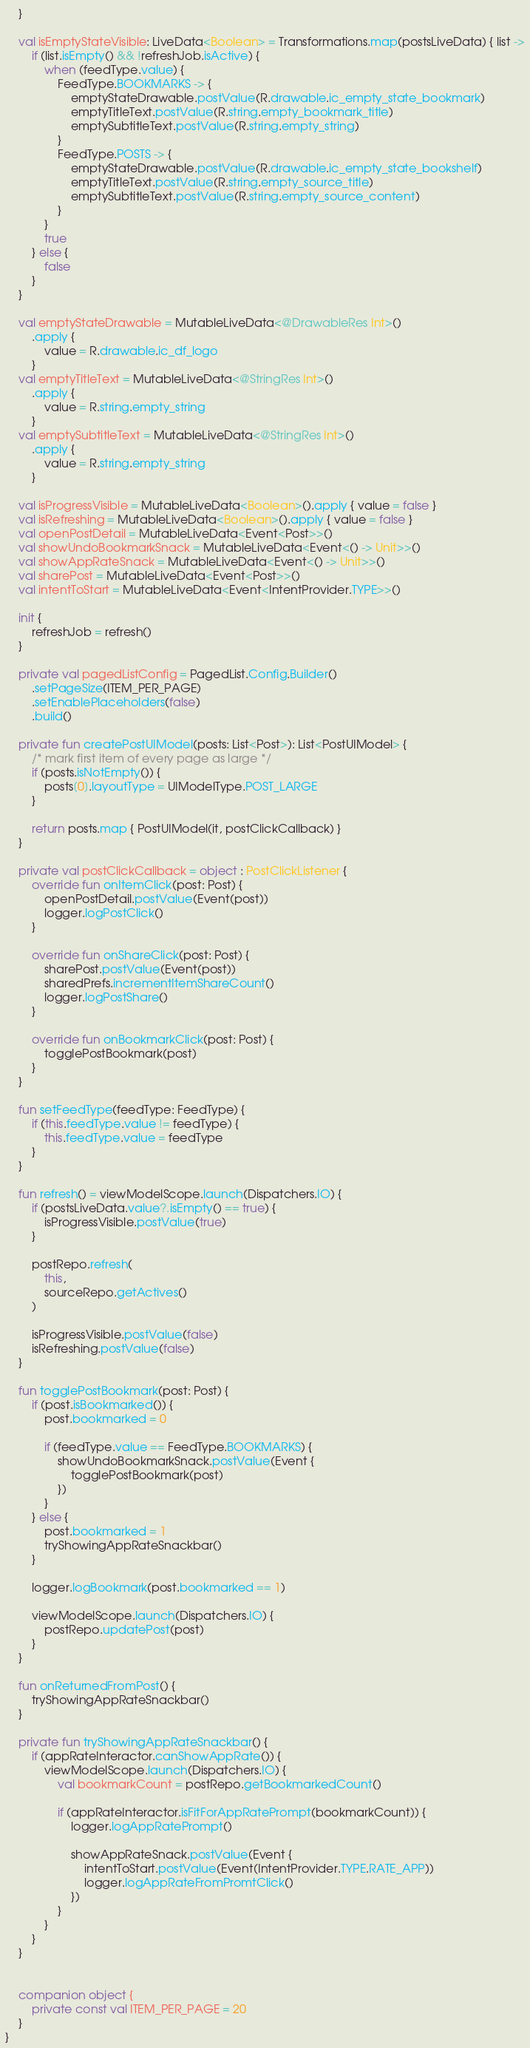<code> <loc_0><loc_0><loc_500><loc_500><_Kotlin_>    }

    val isEmptyStateVisible: LiveData<Boolean> = Transformations.map(postsLiveData) { list ->
        if (list.isEmpty() && !refreshJob.isActive) {
            when (feedType.value) {
                FeedType.BOOKMARKS -> {
                    emptyStateDrawable.postValue(R.drawable.ic_empty_state_bookmark)
                    emptyTitleText.postValue(R.string.empty_bookmark_title)
                    emptySubtitleText.postValue(R.string.empty_string)
                }
                FeedType.POSTS -> {
                    emptyStateDrawable.postValue(R.drawable.ic_empty_state_bookshelf)
                    emptyTitleText.postValue(R.string.empty_source_title)
                    emptySubtitleText.postValue(R.string.empty_source_content)
                }
            }
            true
        } else {
            false
        }
    }

    val emptyStateDrawable = MutableLiveData<@DrawableRes Int>()
        .apply {
            value = R.drawable.ic_df_logo
        }
    val emptyTitleText = MutableLiveData<@StringRes Int>()
        .apply {
            value = R.string.empty_string
        }
    val emptySubtitleText = MutableLiveData<@StringRes Int>()
        .apply {
            value = R.string.empty_string
        }

    val isProgressVisible = MutableLiveData<Boolean>().apply { value = false }
    val isRefreshing = MutableLiveData<Boolean>().apply { value = false }
    val openPostDetail = MutableLiveData<Event<Post>>()
    val showUndoBookmarkSnack = MutableLiveData<Event<() -> Unit>>()
    val showAppRateSnack = MutableLiveData<Event<() -> Unit>>()
    val sharePost = MutableLiveData<Event<Post>>()
    val intentToStart = MutableLiveData<Event<IntentProvider.TYPE>>()

    init {
        refreshJob = refresh()
    }

    private val pagedListConfig = PagedList.Config.Builder()
        .setPageSize(ITEM_PER_PAGE)
        .setEnablePlaceholders(false)
        .build()

    private fun createPostUIModel(posts: List<Post>): List<PostUIModel> {
        /* mark first item of every page as large */
        if (posts.isNotEmpty()) {
            posts[0].layoutType = UIModelType.POST_LARGE
        }

        return posts.map { PostUIModel(it, postClickCallback) }
    }

    private val postClickCallback = object : PostClickListener {
        override fun onItemClick(post: Post) {
            openPostDetail.postValue(Event(post))
            logger.logPostClick()
        }

        override fun onShareClick(post: Post) {
            sharePost.postValue(Event(post))
            sharedPrefs.incrementItemShareCount()
            logger.logPostShare()
        }

        override fun onBookmarkClick(post: Post) {
            togglePostBookmark(post)
        }
    }

    fun setFeedType(feedType: FeedType) {
        if (this.feedType.value != feedType) {
            this.feedType.value = feedType
        }
    }

    fun refresh() = viewModelScope.launch(Dispatchers.IO) {
        if (postsLiveData.value?.isEmpty() == true) {
            isProgressVisible.postValue(true)
        }

        postRepo.refresh(
            this,
            sourceRepo.getActives()
        )

        isProgressVisible.postValue(false)
        isRefreshing.postValue(false)
    }

    fun togglePostBookmark(post: Post) {
        if (post.isBookmarked()) {
            post.bookmarked = 0

            if (feedType.value == FeedType.BOOKMARKS) {
                showUndoBookmarkSnack.postValue(Event {
                    togglePostBookmark(post)
                })
            }
        } else {
            post.bookmarked = 1
            tryShowingAppRateSnackbar()
        }

        logger.logBookmark(post.bookmarked == 1)

        viewModelScope.launch(Dispatchers.IO) {
            postRepo.updatePost(post)
        }
    }

    fun onReturnedFromPost() {
        tryShowingAppRateSnackbar()
    }

    private fun tryShowingAppRateSnackbar() {
        if (appRateInteractor.canShowAppRate()) {
            viewModelScope.launch(Dispatchers.IO) {
                val bookmarkCount = postRepo.getBookmarkedCount()

                if (appRateInteractor.isFitForAppRatePrompt(bookmarkCount)) {
                    logger.logAppRatePrompt()

                    showAppRateSnack.postValue(Event {
                        intentToStart.postValue(Event(IntentProvider.TYPE.RATE_APP))
                        logger.logAppRateFromPromtClick()
                    })
                }
            }
        }
    }


    companion object {
        private const val ITEM_PER_PAGE = 20
    }
}</code> 